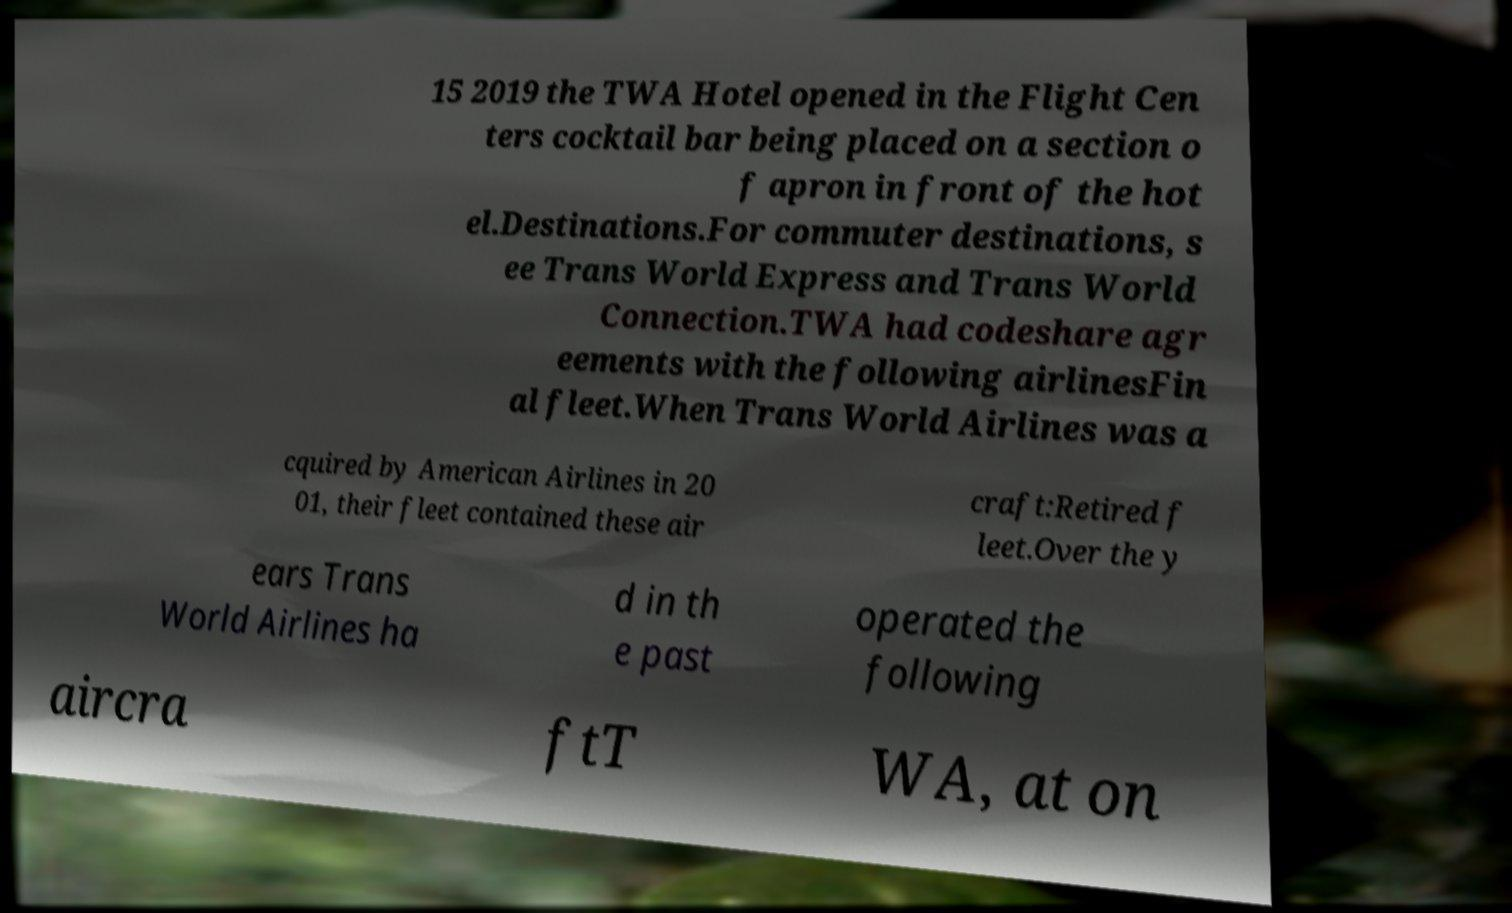Can you accurately transcribe the text from the provided image for me? 15 2019 the TWA Hotel opened in the Flight Cen ters cocktail bar being placed on a section o f apron in front of the hot el.Destinations.For commuter destinations, s ee Trans World Express and Trans World Connection.TWA had codeshare agr eements with the following airlinesFin al fleet.When Trans World Airlines was a cquired by American Airlines in 20 01, their fleet contained these air craft:Retired f leet.Over the y ears Trans World Airlines ha d in th e past operated the following aircra ftT WA, at on 